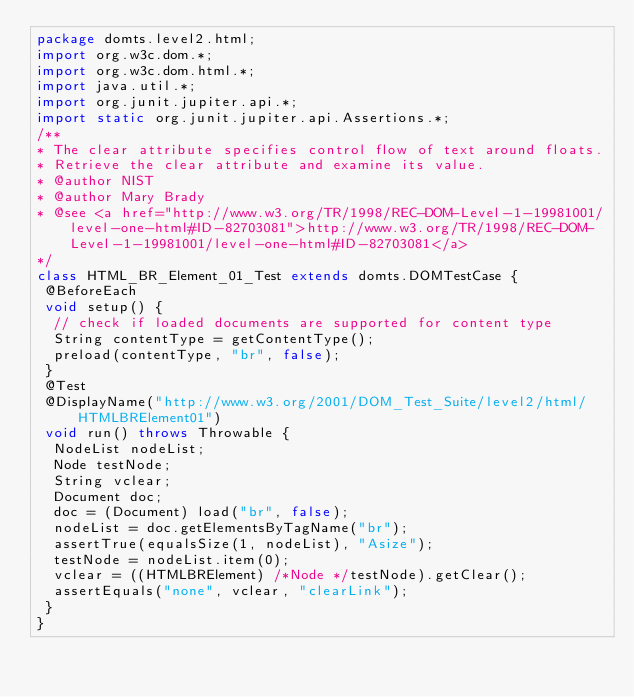<code> <loc_0><loc_0><loc_500><loc_500><_Java_>package domts.level2.html;
import org.w3c.dom.*;
import org.w3c.dom.html.*;
import java.util.*;
import org.junit.jupiter.api.*;
import static org.junit.jupiter.api.Assertions.*;
/**
* The clear attribute specifies control flow of text around floats. 
* Retrieve the clear attribute and examine its value.  
* @author NIST
* @author Mary Brady
* @see <a href="http://www.w3.org/TR/1998/REC-DOM-Level-1-19981001/level-one-html#ID-82703081">http://www.w3.org/TR/1998/REC-DOM-Level-1-19981001/level-one-html#ID-82703081</a>
*/
class HTML_BR_Element_01_Test extends domts.DOMTestCase {
 @BeforeEach
 void setup() {
  // check if loaded documents are supported for content type
  String contentType = getContentType();
  preload(contentType, "br", false);
 }
 @Test
 @DisplayName("http://www.w3.org/2001/DOM_Test_Suite/level2/html/HTMLBRElement01")
 void run() throws Throwable {
  NodeList nodeList;
  Node testNode;
  String vclear;
  Document doc;
  doc = (Document) load("br", false);
  nodeList = doc.getElementsByTagName("br");
  assertTrue(equalsSize(1, nodeList), "Asize");
  testNode = nodeList.item(0);
  vclear = ((HTMLBRElement) /*Node */testNode).getClear();
  assertEquals("none", vclear, "clearLink");
 }
}</code> 